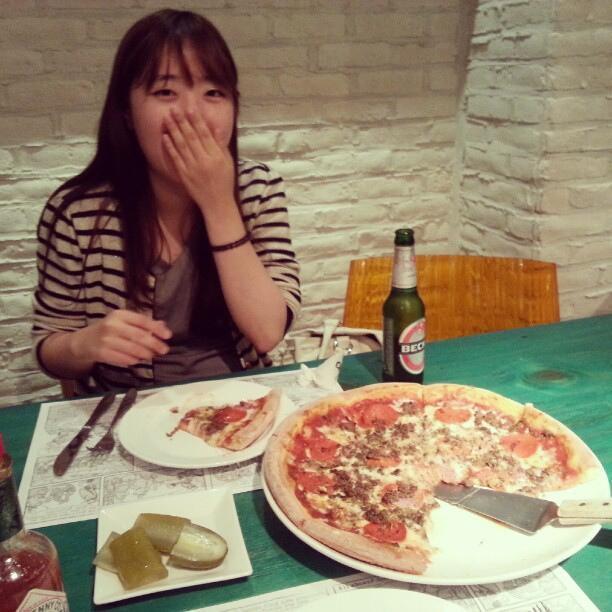How many pizzas are in the picture?
Give a very brief answer. 2. How many cats are there?
Give a very brief answer. 0. 